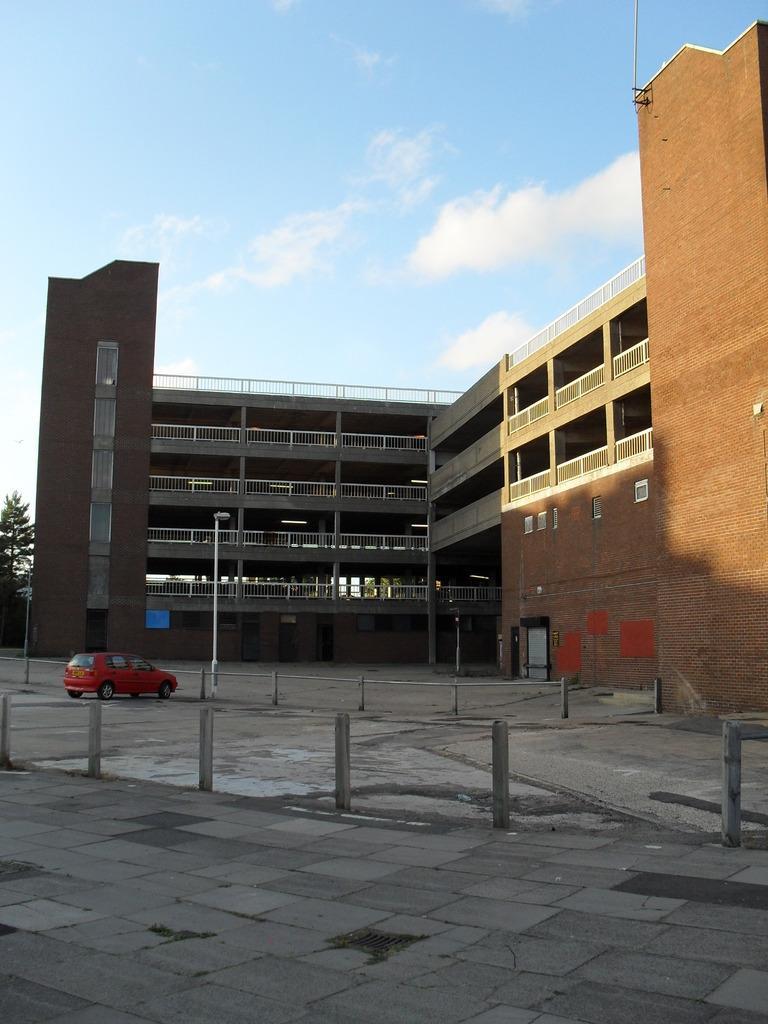Please provide a concise description of this image. In this image there is the sky, there are clouds in the sky, there is a building truncated, there is a tree truncated towards the left of the image, there is a streetlight, there is a pole, there is a car, there is a fencing, there is an object truncated towards the right of the image. 